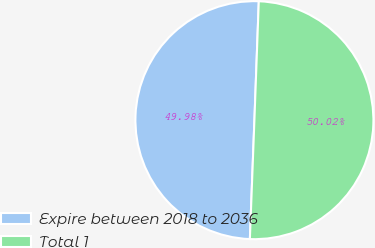Convert chart to OTSL. <chart><loc_0><loc_0><loc_500><loc_500><pie_chart><fcel>Expire between 2018 to 2036<fcel>Total 1<nl><fcel>49.98%<fcel>50.02%<nl></chart> 